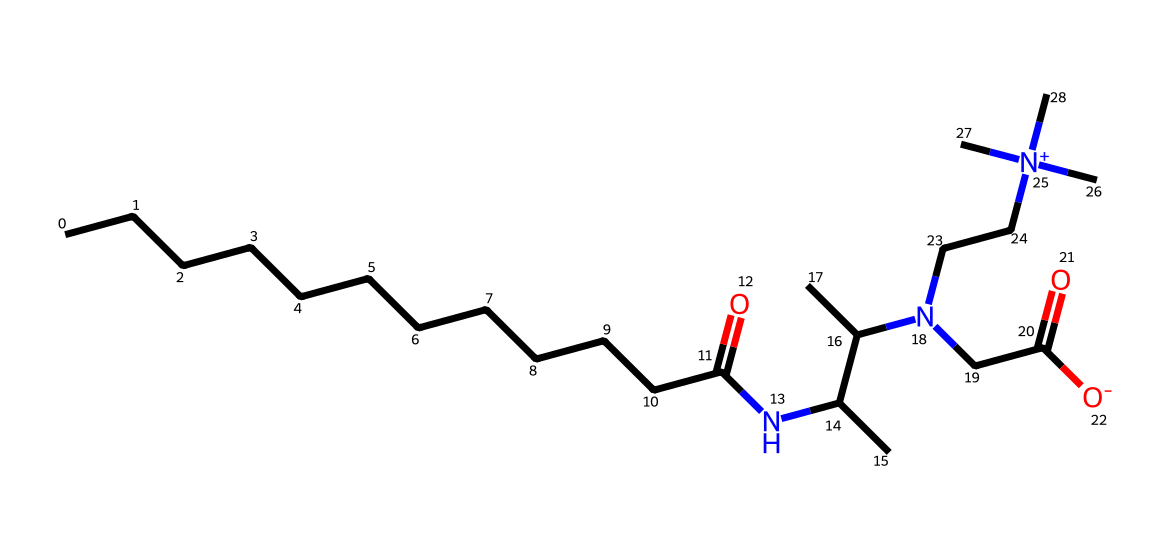What is the total number of carbon atoms in the structure? Count all the 'C' symbols in the SMILES representation. The chemical contains 16 'C' symbols, indicating a total of 16 carbon atoms.
Answer: 16 How many nitrogen atoms are present in this chemical? Identify the 'N' symbols in the SMILES representation. In total, there are 3 'N' symbols, indicating the presence of 3 nitrogen atoms.
Answer: 3 What type of functional group is present at the end of the carbon chain? The end of the carbon chain is a carbonyl group (C=O), which is characteristic of amides and acids. Here, it indicates the presence of a carboxamide (amide functional group).
Answer: amide What characteristic of cocamidopropyl betaine makes it a mild surfactant? Advise that the presence of a quaternary ammonium compound (indicated by the positively charged nitrogen) enhances its surfactant properties while maintaining mildness. The balance of hydrophilic and hydrophobic components contributes to its mildness.
Answer: balance of hydrophilic and hydrophobic What is the purpose of the positive charge on the nitrogen atom in cocamidopropyl betaine? The positive charge on the nitrogen indicates that this is a surfactant, which helps it to interact with both water and oils, breaking down dirt and grime effectively while being gentle on the skin.
Answer: surfactant action How many oxygen atoms are present in the structure? Count the 'O' symbols in the SMILES. There are 4 'O' symbols in the representation, indicating the presence of 4 oxygen atoms overall.
Answer: 4 What type of surfactant is cocamidopropyl betaine classified as? Given its chemical structure and properties, cocamidopropyl betaine is classified as an amphoteric surfactant, which can behave as both a cationic and anionic surfactant depending on the pH of the solution.
Answer: amphoteric 